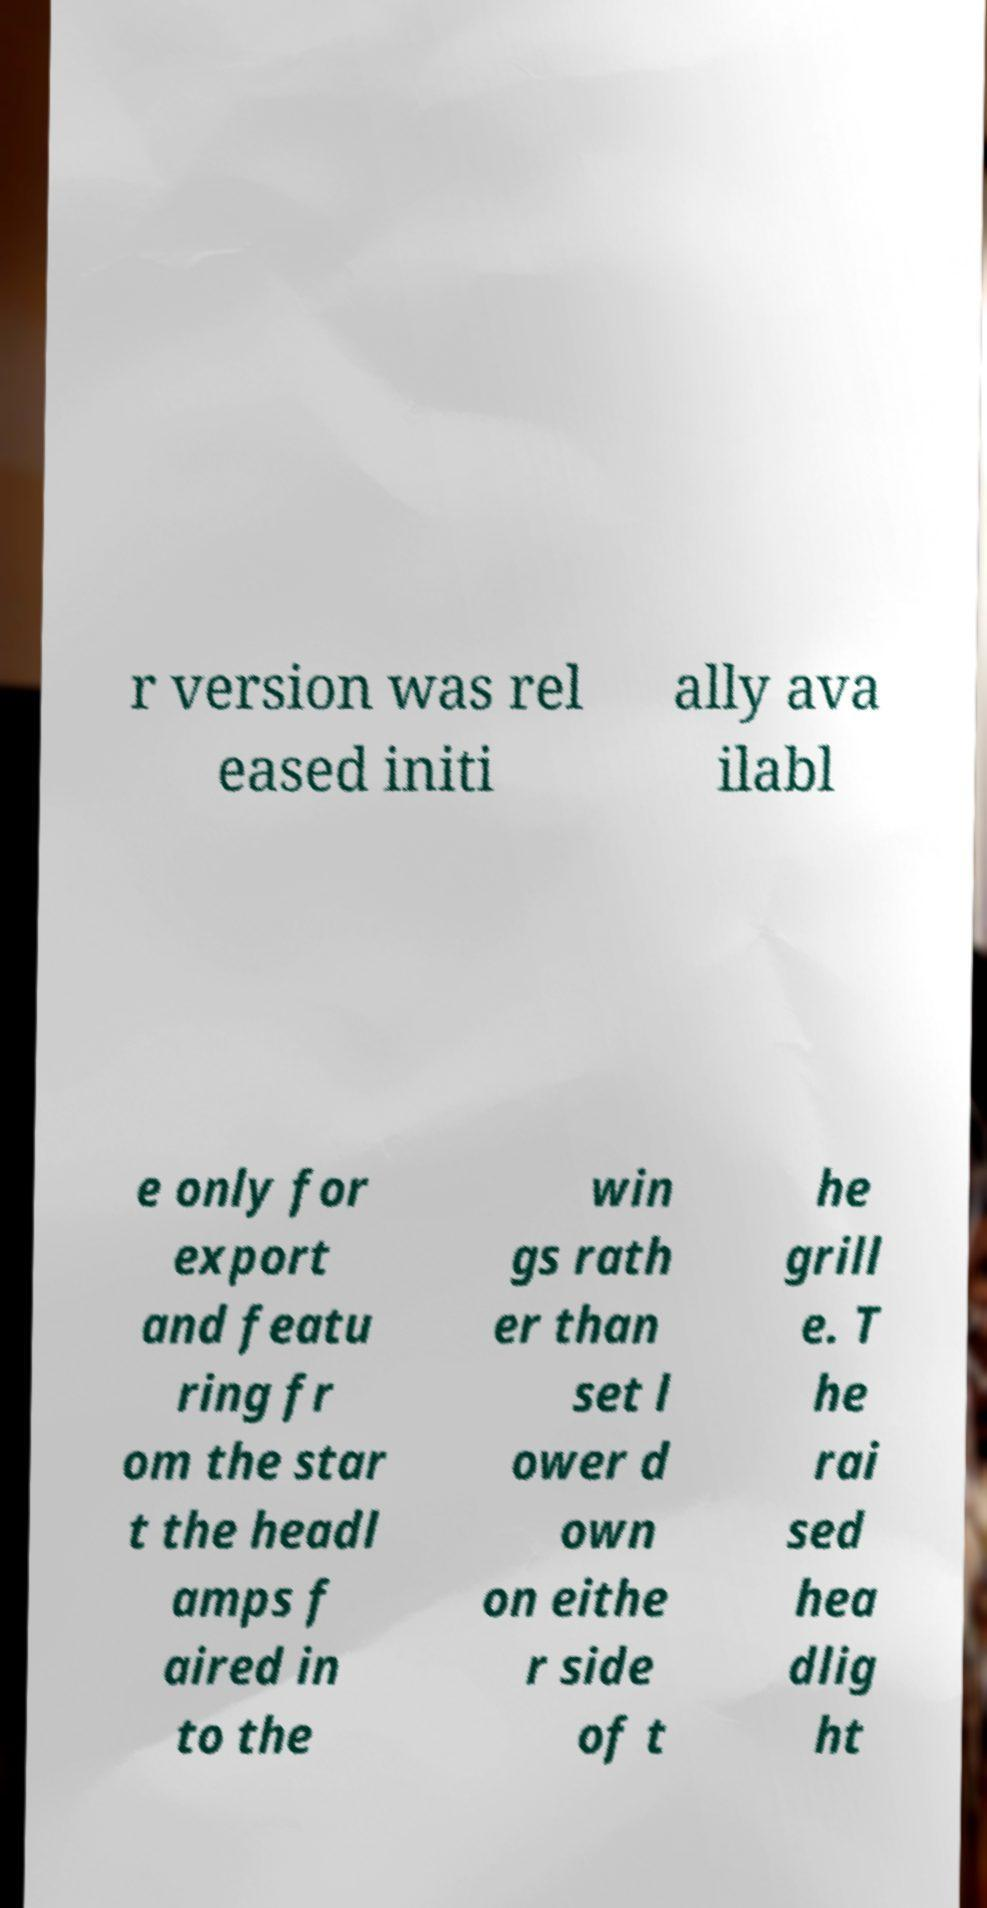Can you accurately transcribe the text from the provided image for me? r version was rel eased initi ally ava ilabl e only for export and featu ring fr om the star t the headl amps f aired in to the win gs rath er than set l ower d own on eithe r side of t he grill e. T he rai sed hea dlig ht 